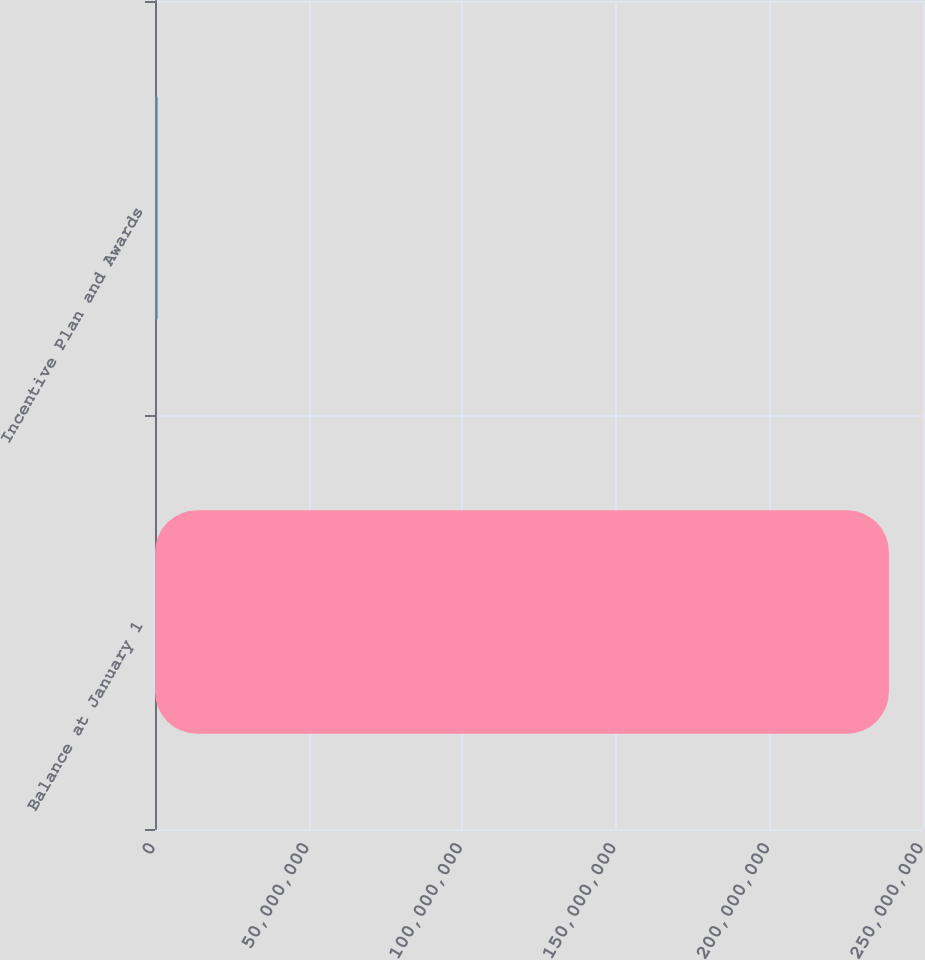<chart> <loc_0><loc_0><loc_500><loc_500><bar_chart><fcel>Balance at January 1<fcel>Incentive Plan and Awards<nl><fcel>2.38915e+08<fcel>863958<nl></chart> 